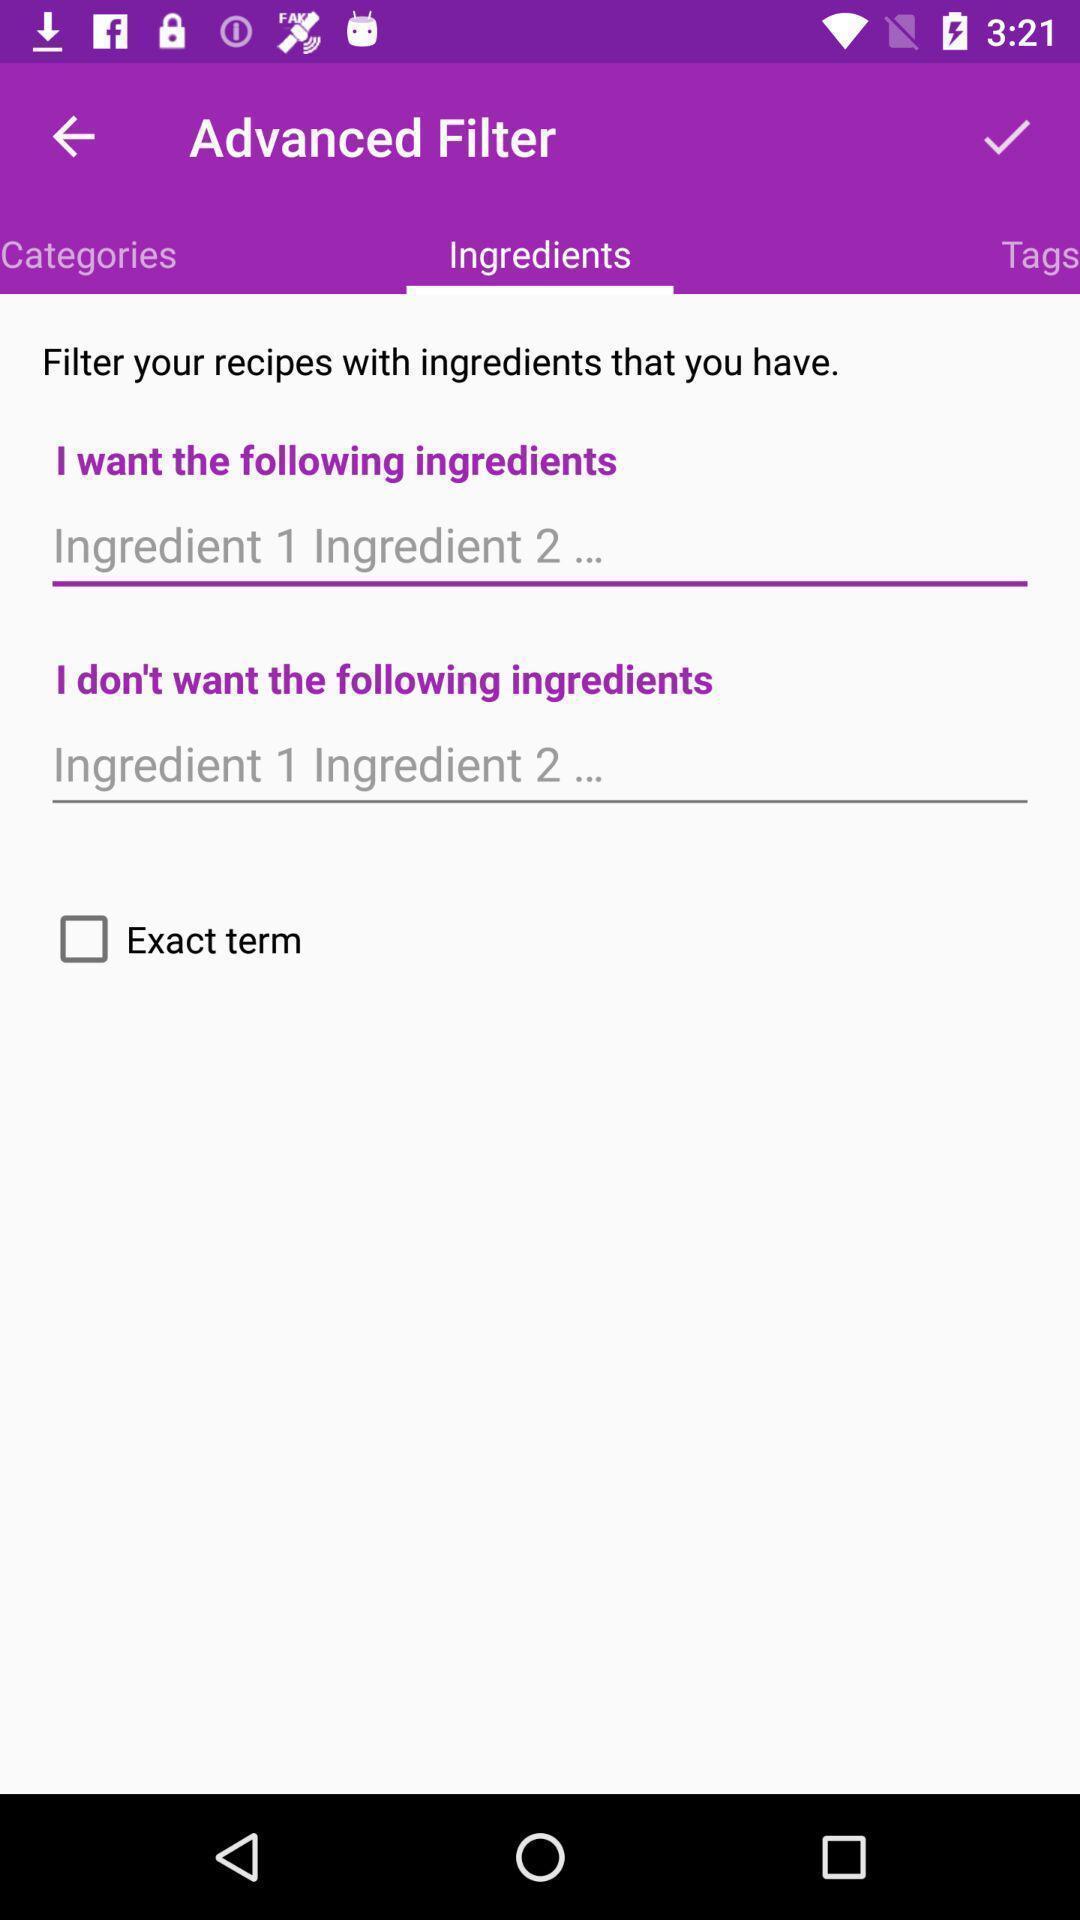Explain what's happening in this screen capture. Screen displaying multiple ingredients options. 